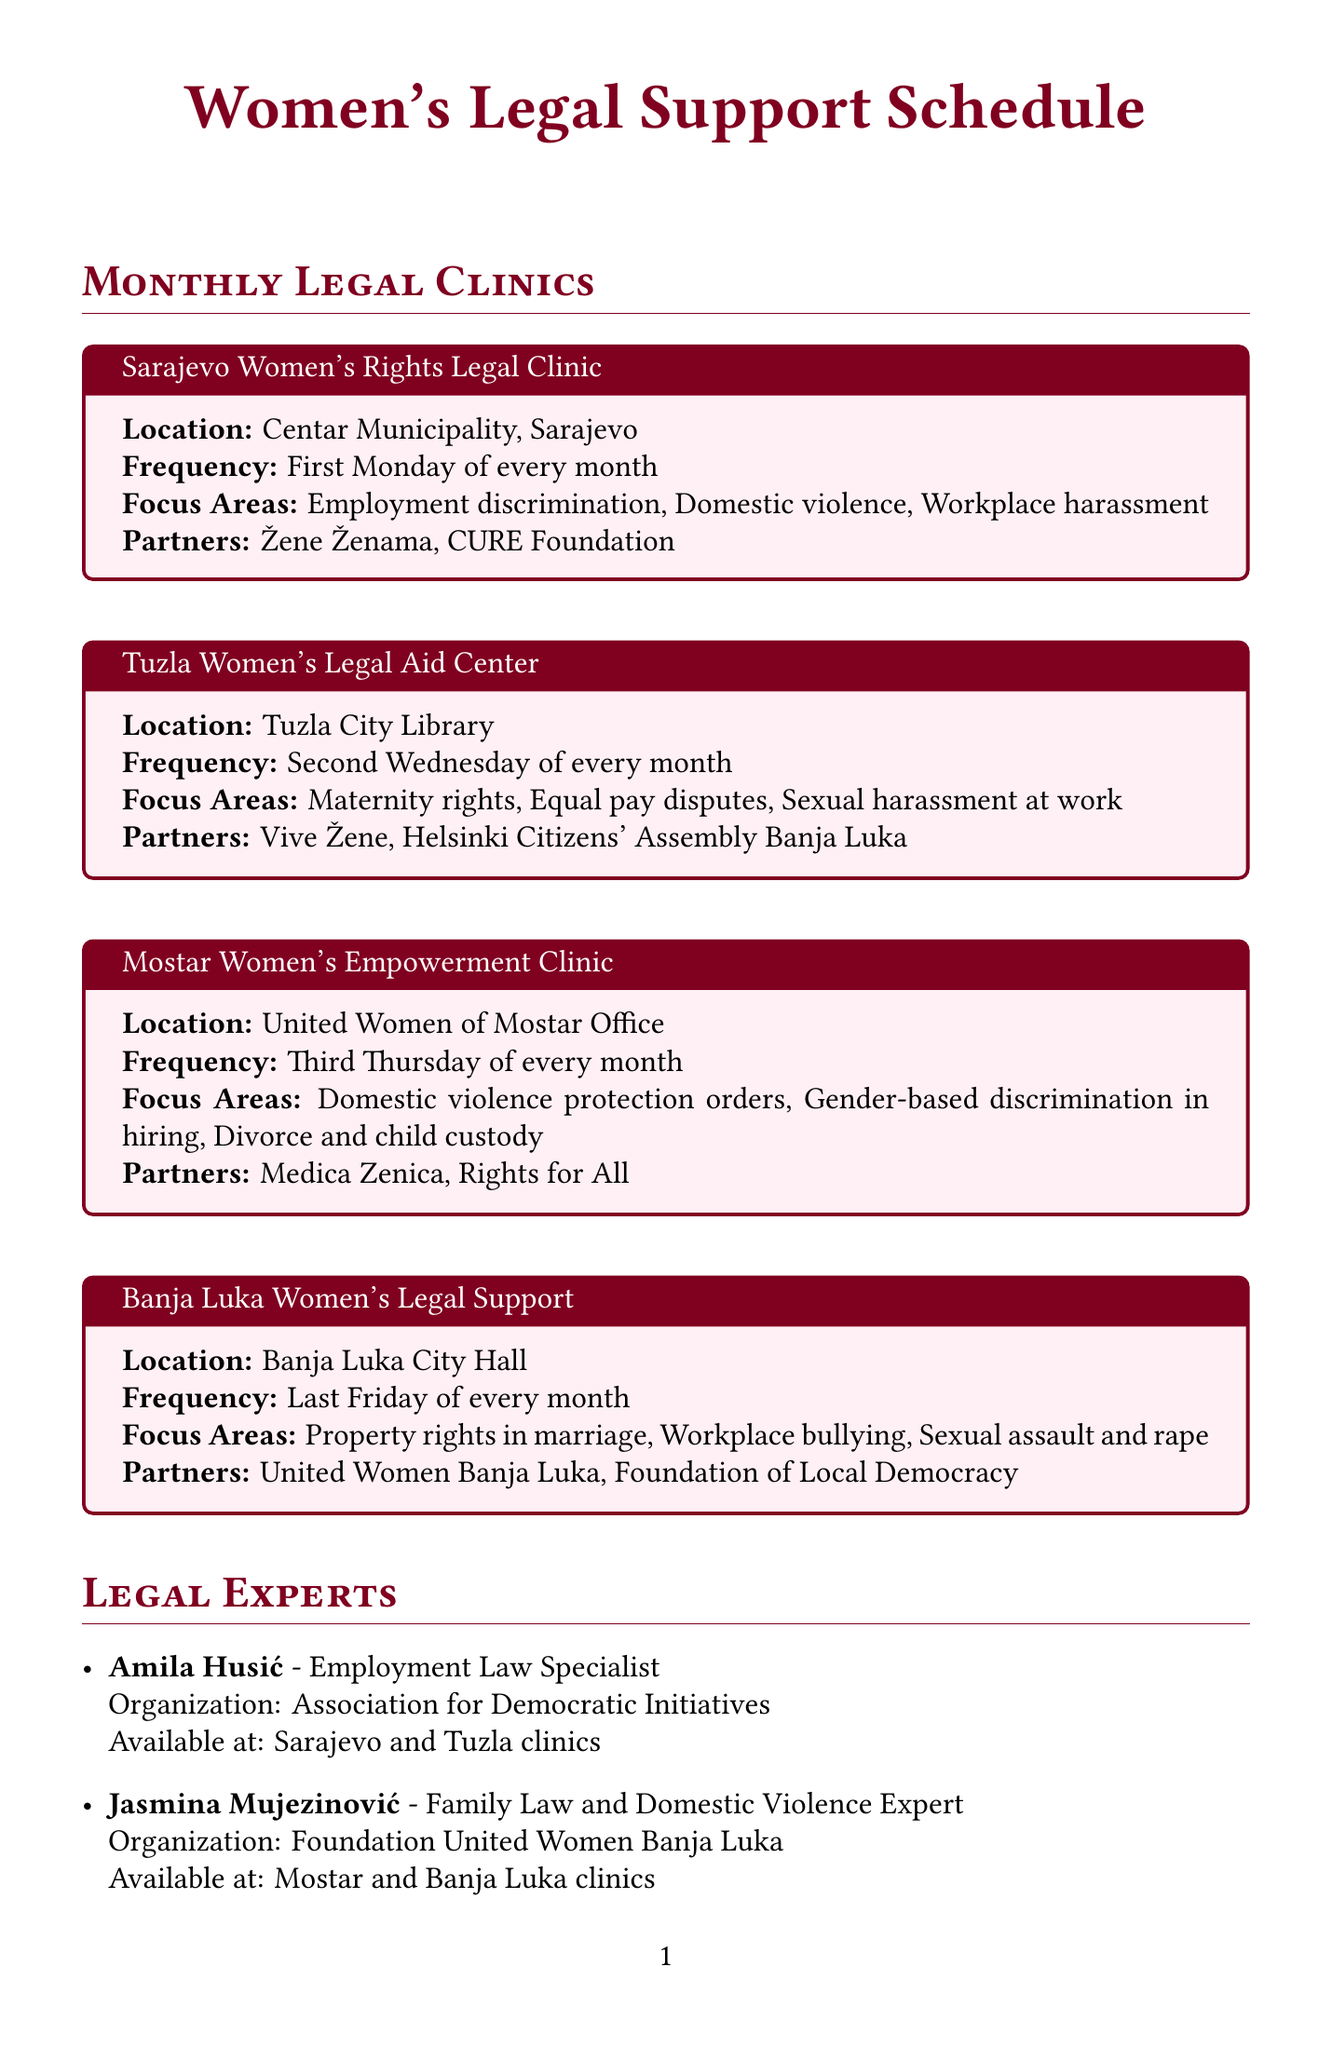What is the location of the Sarajevo Women's Rights Legal Clinic? The location of the Sarajevo Women's Rights Legal Clinic is specified in the document.
Answer: Centar Municipality, Sarajevo When is the Tuzla Women's Legal Aid Center held? The frequency of the Tuzla Women's Legal Aid Center is stated clearly in the document.
Answer: Second Wednesday of every month What focus area is addressed by the Banja Luka Women's Legal Support? The focus areas of the Banja Luka Women's Legal Support are listed in the document.
Answer: Property rights in marriage How often do legal clinics occur in Mostar? The document provides the frequency for Mostar Women's Empowerment Clinic.
Answer: Third Thursday of every month Which organization partners with the Sarajevo Women's Rights Legal Clinic? Partnering organizations are mentioned for each legal clinic.
Answer: Žene Ženama Who specializes in Family Law and Domestic Violence? The document describes the specialization of legal experts available at the clinics.
Answer: Jasmina Mujezinović What services does the Gender Centre of Federation of Bosnia and Herzegovina provide? Information on services is provided under the support services section.
Answer: Policy advocacy, Research, Education What is the phone number for the SOS Helpline for Victims of Violence? The SOS Helpline's contact information is specified in the document.
Answer: 1265 When does the 16 Days of Activism Against Gender-Based Violence take place? The date range for the campaign is clearly mentioned in the document.
Answer: November 25 - December 10 What are the activities planned for Equal Pay Day? The document lists the activities related to the campaign.
Answer: Media campaigns, Round table discussions, Petition signing 